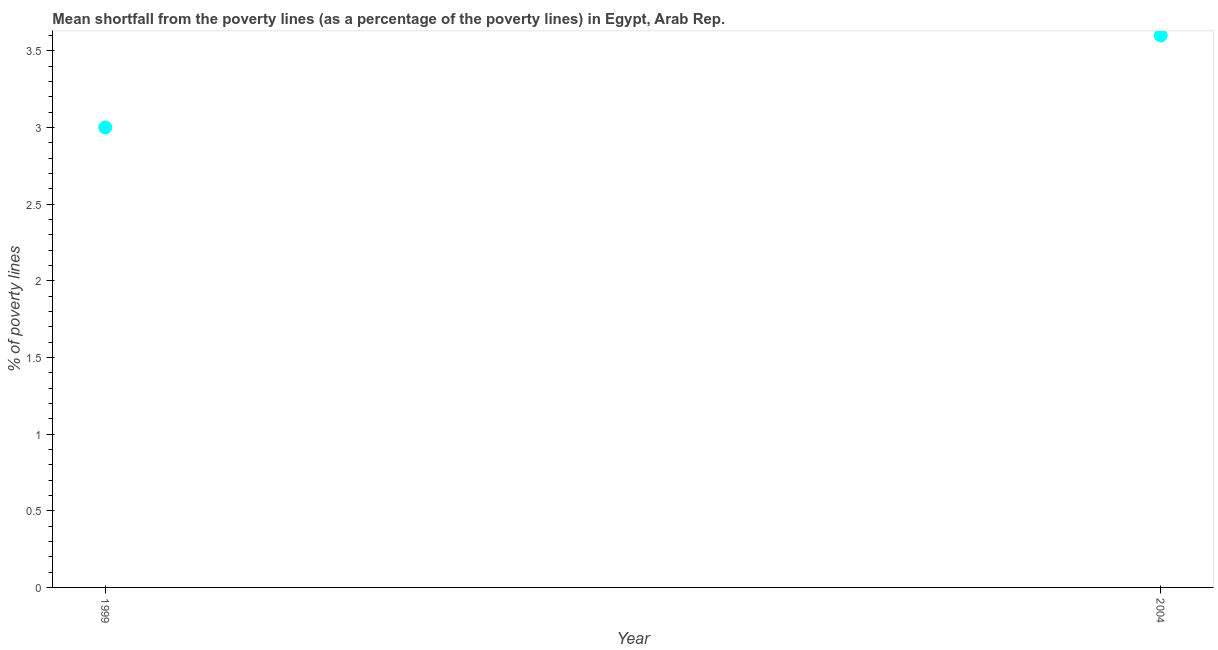What is the poverty gap at national poverty lines in 1999?
Offer a very short reply. 3. Across all years, what is the minimum poverty gap at national poverty lines?
Offer a very short reply. 3. In which year was the poverty gap at national poverty lines maximum?
Your response must be concise. 2004. What is the difference between the poverty gap at national poverty lines in 1999 and 2004?
Provide a short and direct response. -0.6. What is the median poverty gap at national poverty lines?
Ensure brevity in your answer.  3.3. What is the ratio of the poverty gap at national poverty lines in 1999 to that in 2004?
Your answer should be compact. 0.83. In how many years, is the poverty gap at national poverty lines greater than the average poverty gap at national poverty lines taken over all years?
Your answer should be very brief. 1. Does the poverty gap at national poverty lines monotonically increase over the years?
Ensure brevity in your answer.  Yes. How many dotlines are there?
Ensure brevity in your answer.  1. What is the difference between two consecutive major ticks on the Y-axis?
Keep it short and to the point. 0.5. Are the values on the major ticks of Y-axis written in scientific E-notation?
Make the answer very short. No. Does the graph contain any zero values?
Give a very brief answer. No. Does the graph contain grids?
Give a very brief answer. No. What is the title of the graph?
Keep it short and to the point. Mean shortfall from the poverty lines (as a percentage of the poverty lines) in Egypt, Arab Rep. What is the label or title of the Y-axis?
Keep it short and to the point. % of poverty lines. What is the ratio of the % of poverty lines in 1999 to that in 2004?
Your response must be concise. 0.83. 